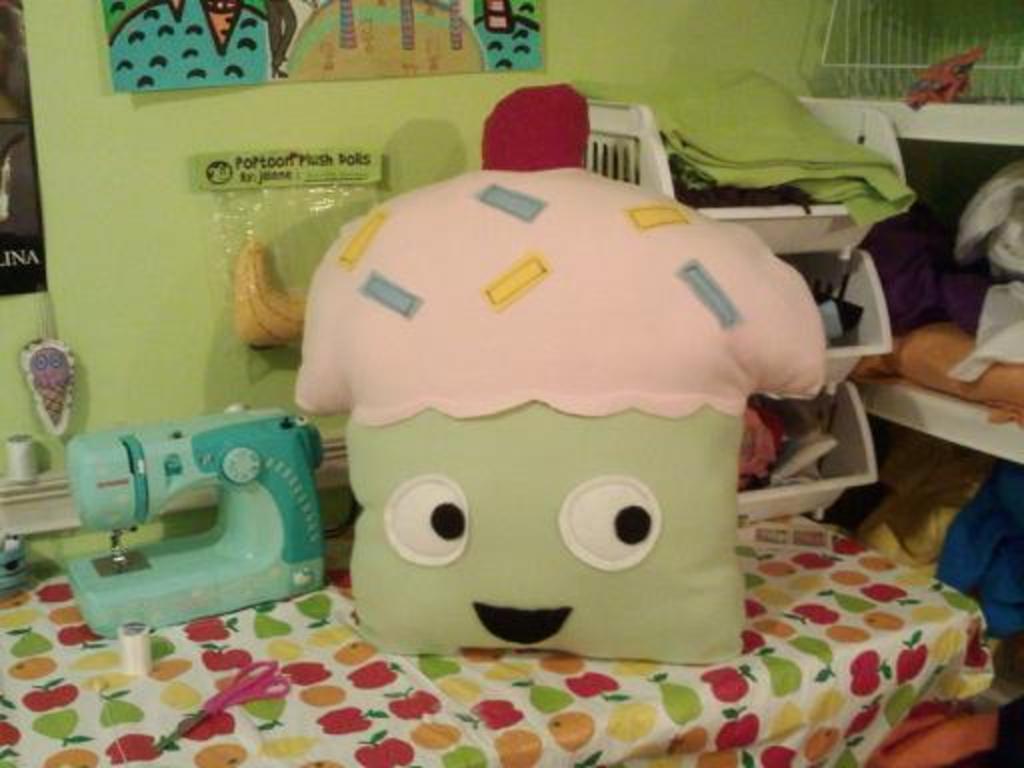Describe this image in one or two sentences. In this picture we can see pillow, machine and objects on the stand and we can see clothes in stand. We can see clothes and objects on shelves. In the background of the image we can see packet and boards on the wall. 